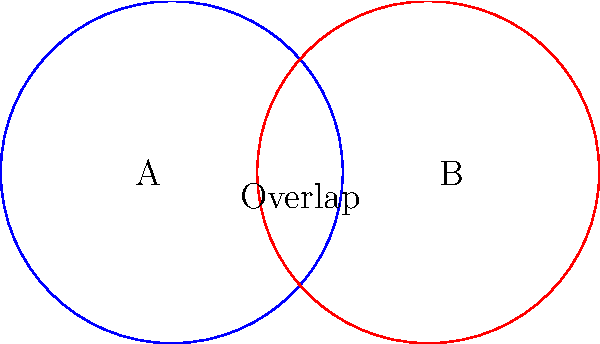In audio production, two overlapping frequency spectrums are represented by circles A and B, each with a radius of 1 unit. If the distance between their centers is 1.5 units, calculate the area of the overlapping region. Round your answer to two decimal places. To find the area of the overlapping region, we'll follow these steps:

1. Recognize that this is a case of two intersecting circles.

2. The area of the overlapping region can be calculated using the formula:
   $$A = 2r^2 \arccos(\frac{d}{2r}) - d\sqrt{r^2 - \frac{d^2}{4}}$$
   where $r$ is the radius of each circle and $d$ is the distance between their centers.

3. We're given:
   $r = 1$ unit
   $d = 1.5$ units

4. Substitute these values into the formula:
   $$A = 2(1)^2 \arccos(\frac{1.5}{2(1)}) - 1.5\sqrt{(1)^2 - \frac{(1.5)^2}{4}}$$

5. Simplify:
   $$A = 2 \arccos(0.75) - 1.5\sqrt{1 - 0.5625}$$
   $$A = 2 \arccos(0.75) - 1.5\sqrt{0.4375}$$

6. Calculate:
   $$A \approx 2(0.7227) - 1.5(0.6614)$$
   $$A \approx 1.4454 - 0.9921$$
   $$A \approx 0.4533$$

7. Rounding to two decimal places:
   $$A \approx 0.45 \text{ square units}$$

This overlapping area represents the shared frequency content between the two audio spectrums, which is crucial for understanding how to blend or separate these frequencies in audio production.
Answer: 0.45 square units 